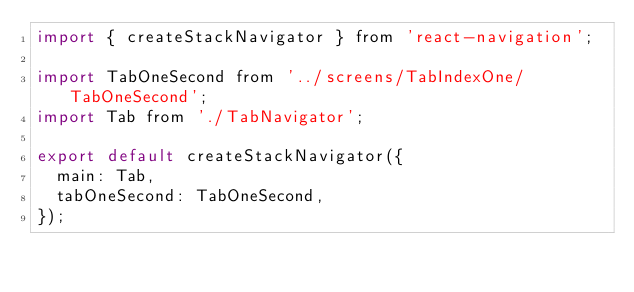<code> <loc_0><loc_0><loc_500><loc_500><_JavaScript_>import { createStackNavigator } from 'react-navigation';

import TabOneSecond from '../screens/TabIndexOne/TabOneSecond';
import Tab from './TabNavigator';

export default createStackNavigator({
  main: Tab,
  tabOneSecond: TabOneSecond,
});
</code> 